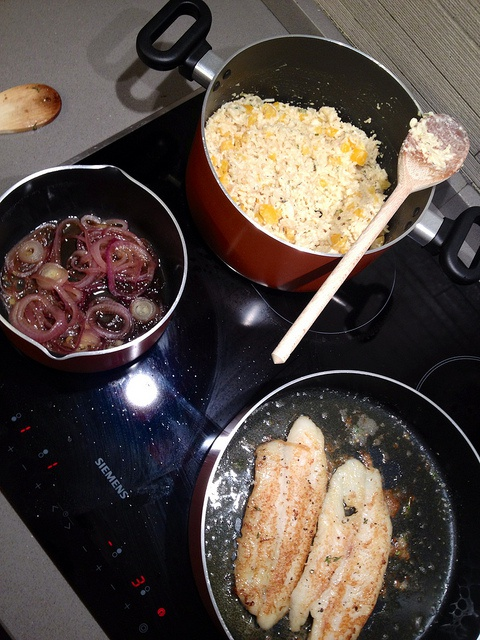Describe the objects in this image and their specific colors. I can see bowl in gray, black, tan, beige, and maroon tones, bowl in gray, black, maroon, and brown tones, and spoon in gray, ivory, tan, and darkgray tones in this image. 